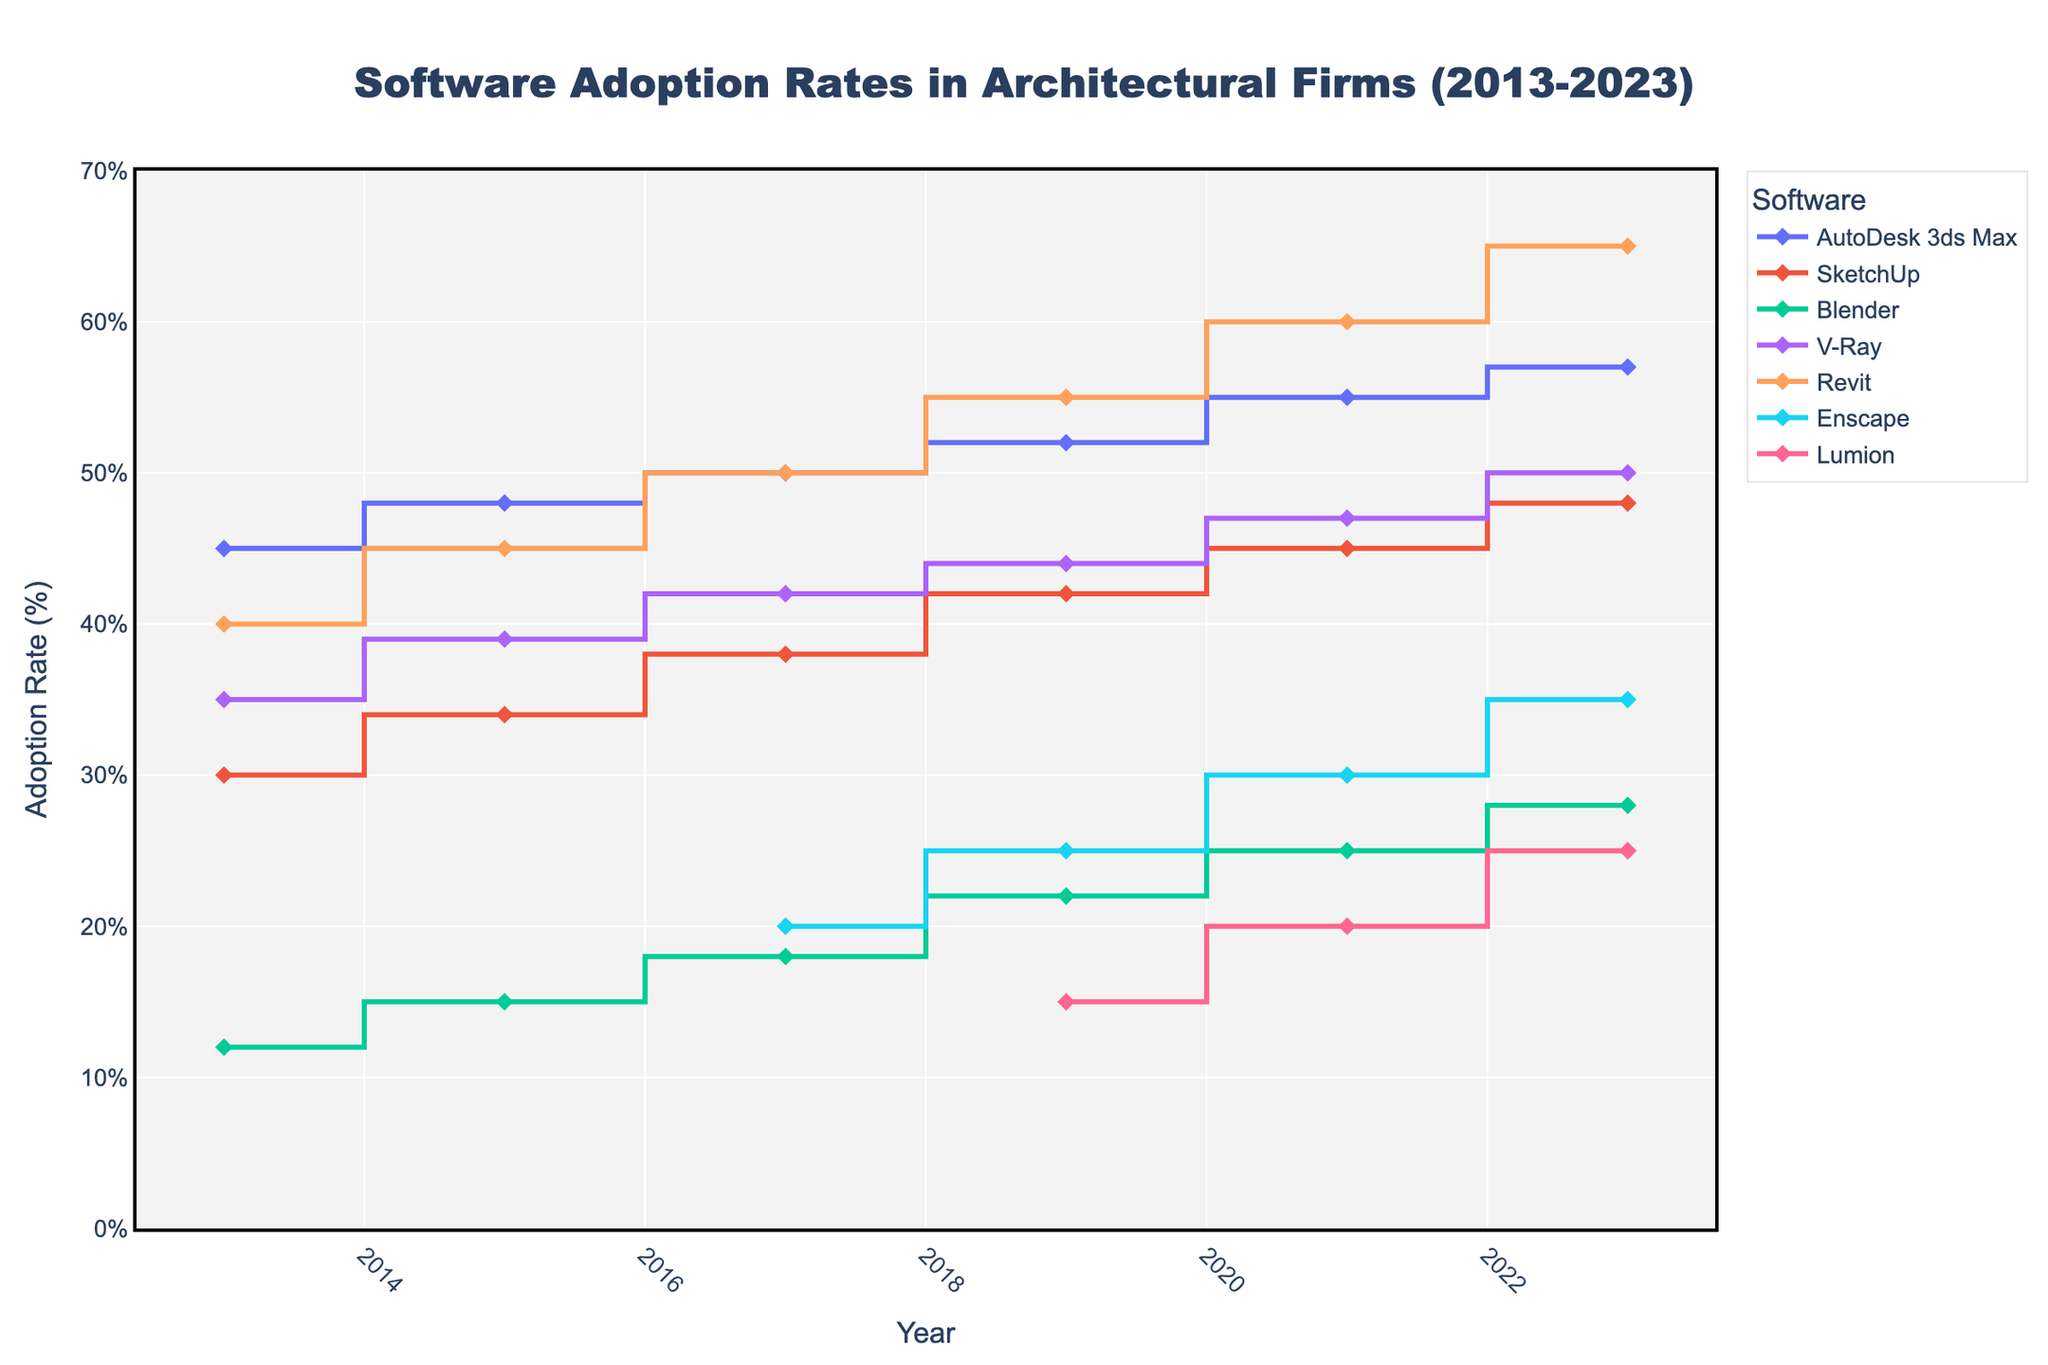What is the adoption rate of Revit in 2023? Look at the data point for Revit in the year 2023 on the plot.
Answer: 65% How did the adoption rate of SketchUp change from 2013 to 2023? Observe the SketchUp data points in 2013 and 2023. SketchUp started at 30% in 2013 and increased to 48% in 2023. The change is 48% - 30% = 18%.
Answer: Increased by 18% Which software had the highest adoption rate in 2021? Compare the adoption rates of all software in the year 2021. Revit has the highest adoption rate with 60%.
Answer: Revit Between 2015 and 2017, which software saw the largest increase in adoption rate? Compare the adoption rates from 2015 to 2017 for each software and calculate the differences. AutoDesk 3ds Max increased by 2% (50%-48%), SketchUp by 4% (38%-34%), Blender by 3% (18%-15%), V-Ray by 3% (42%-39%), Enscape introduced in 2017, and Revit by 5% (50%-45%).
Answer: Revit What's the median adoption rate of V-Ray over the decade? List out the adoption rates of V-Ray over the years: 2013 (35%), 2015 (39%), 2017 (42%), 2019 (44%), 2021 (47%), 2023 (50%). The median value is the average of the two middle values when sorted: (42% + 44%) / 2 = 43%.
Answer: 43% Which year did autoDesk 3ds Max have an adoption rate of 52%? Locate the year on the plot where AutoDesk 3ds Max’s adoption rate is shown as 52%.
Answer: 2019 Did Lumion see an increase or decrease in adoption rate from 2019 to 2023, and by how much? Look at Lumion data points for 2019 and 2023. It went from 15% in 2019 to 25% in 2023. So it increased by 25% - 15% = 10%.
Answer: Increased by 10% Which software was introduced to the plot after 2015? Identify software that did not appear on the plot before 2015 but appeared later. Enscape was introduced in 2017, and Lumion in 2019.
Answer: Enscape, Lumion Compared to Blender, how did the adoption rate of V-Ray change from 2013 to 2023? Look at the adoption rates of V-Ray and Blender in 2013 and 2023. V-Ray increased from 35% to 50% (15% increase), while Blender increased from 12% to 28% (16% increase). V-Ray has less percentage increase than Blender.
Answer: V-Ray increased less What is the overall trend in adoption rate for Autodesk 3ds Max over the ten years? Observe the adoption rates of AutoDesk 3ds Max from 2013 to 2023. The adoption rate steadily increased over the decade from 45% to 57%.
Answer: Increasing 